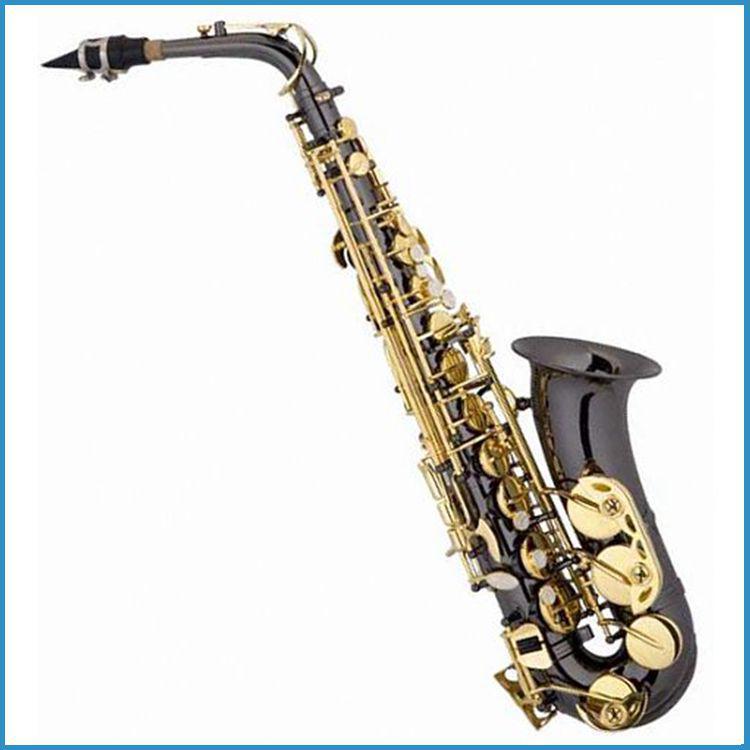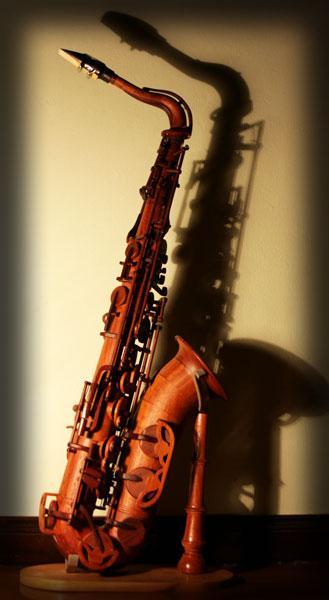The first image is the image on the left, the second image is the image on the right. Considering the images on both sides, is "The saxophones are standing against a white background" valid? Answer yes or no. No. 